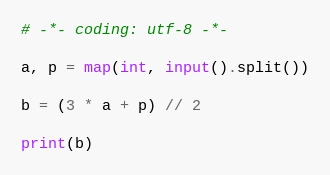<code> <loc_0><loc_0><loc_500><loc_500><_Python_># -*- coding: utf-8 -*-

a, p = map(int, input().split())

b = (3 * a + p) // 2

print(b)</code> 